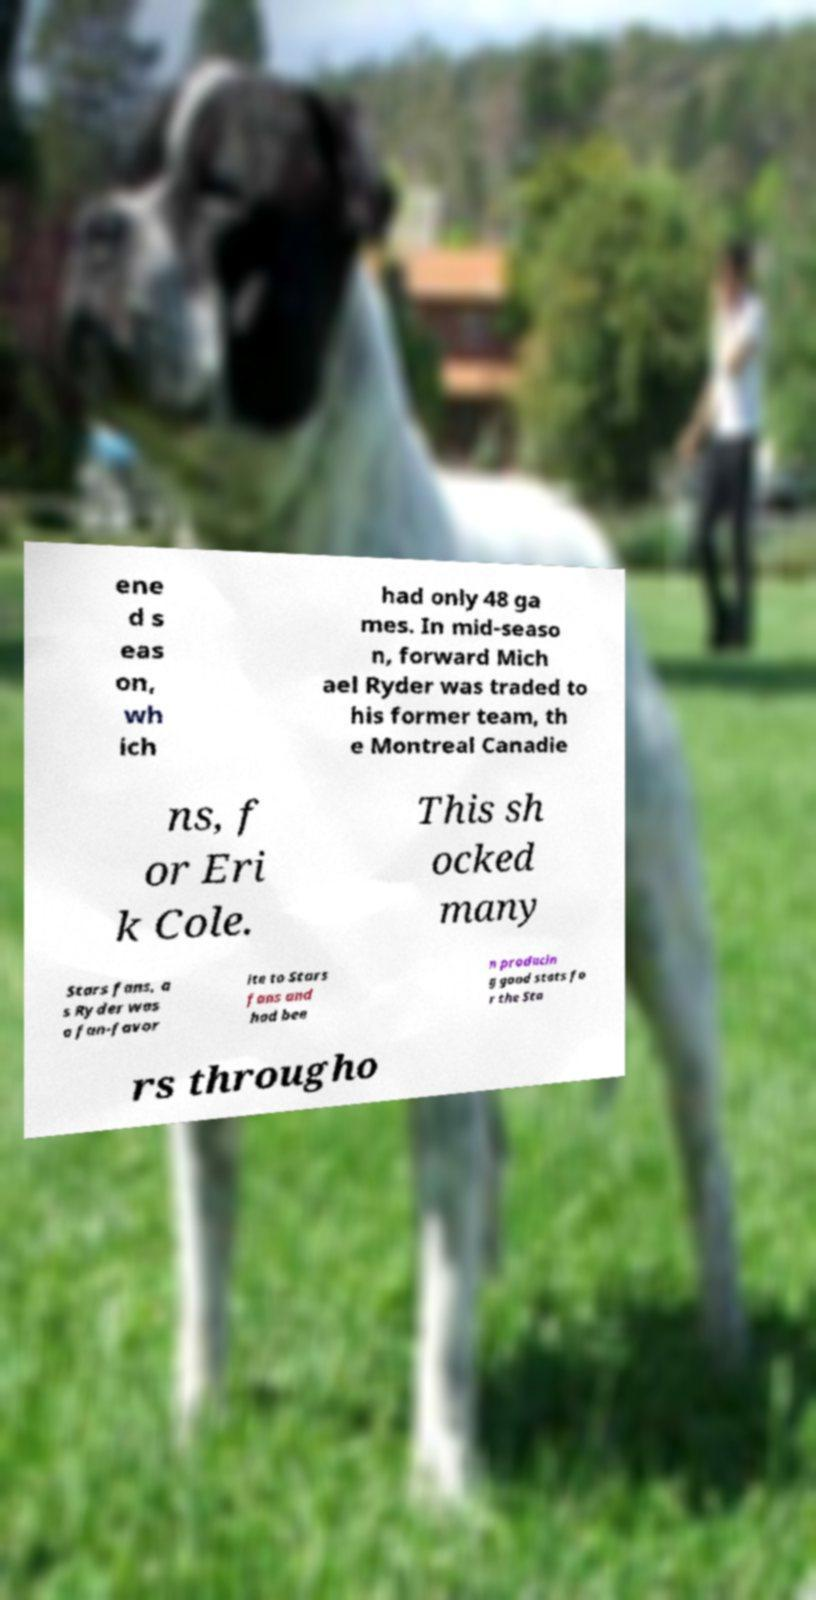Can you read and provide the text displayed in the image?This photo seems to have some interesting text. Can you extract and type it out for me? ene d s eas on, wh ich had only 48 ga mes. In mid-seaso n, forward Mich ael Ryder was traded to his former team, th e Montreal Canadie ns, f or Eri k Cole. This sh ocked many Stars fans, a s Ryder was a fan-favor ite to Stars fans and had bee n producin g good stats fo r the Sta rs througho 